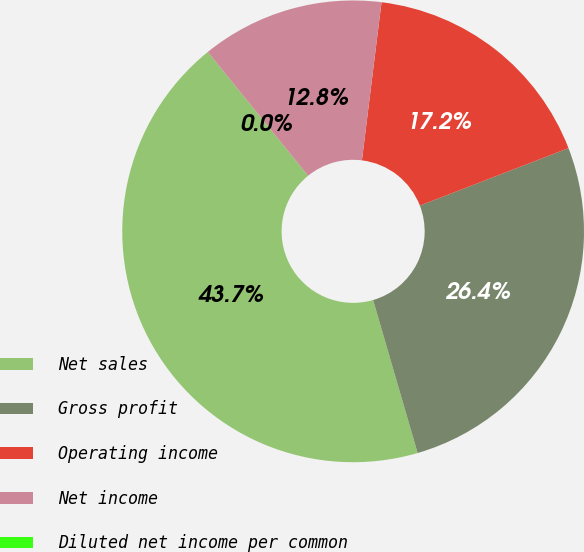Convert chart. <chart><loc_0><loc_0><loc_500><loc_500><pie_chart><fcel>Net sales<fcel>Gross profit<fcel>Operating income<fcel>Net income<fcel>Diluted net income per common<nl><fcel>43.67%<fcel>26.36%<fcel>17.17%<fcel>12.8%<fcel>0.0%<nl></chart> 